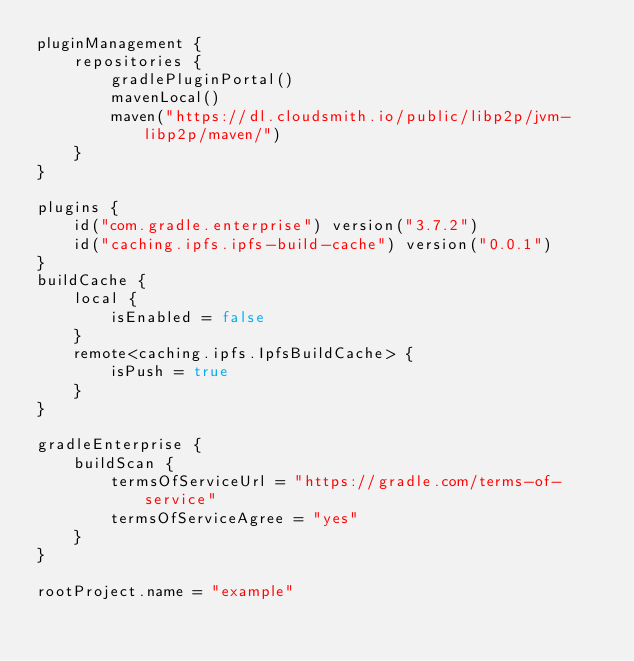<code> <loc_0><loc_0><loc_500><loc_500><_Kotlin_>pluginManagement {
    repositories {
        gradlePluginPortal()
        mavenLocal()
        maven("https://dl.cloudsmith.io/public/libp2p/jvm-libp2p/maven/")
    }
}

plugins {
    id("com.gradle.enterprise") version("3.7.2")
    id("caching.ipfs.ipfs-build-cache") version("0.0.1")
}
buildCache {
    local {
        isEnabled = false
    }
    remote<caching.ipfs.IpfsBuildCache> {
        isPush = true
    }
}

gradleEnterprise {
    buildScan {
        termsOfServiceUrl = "https://gradle.com/terms-of-service"
        termsOfServiceAgree = "yes"
    }
}

rootProject.name = "example"
</code> 